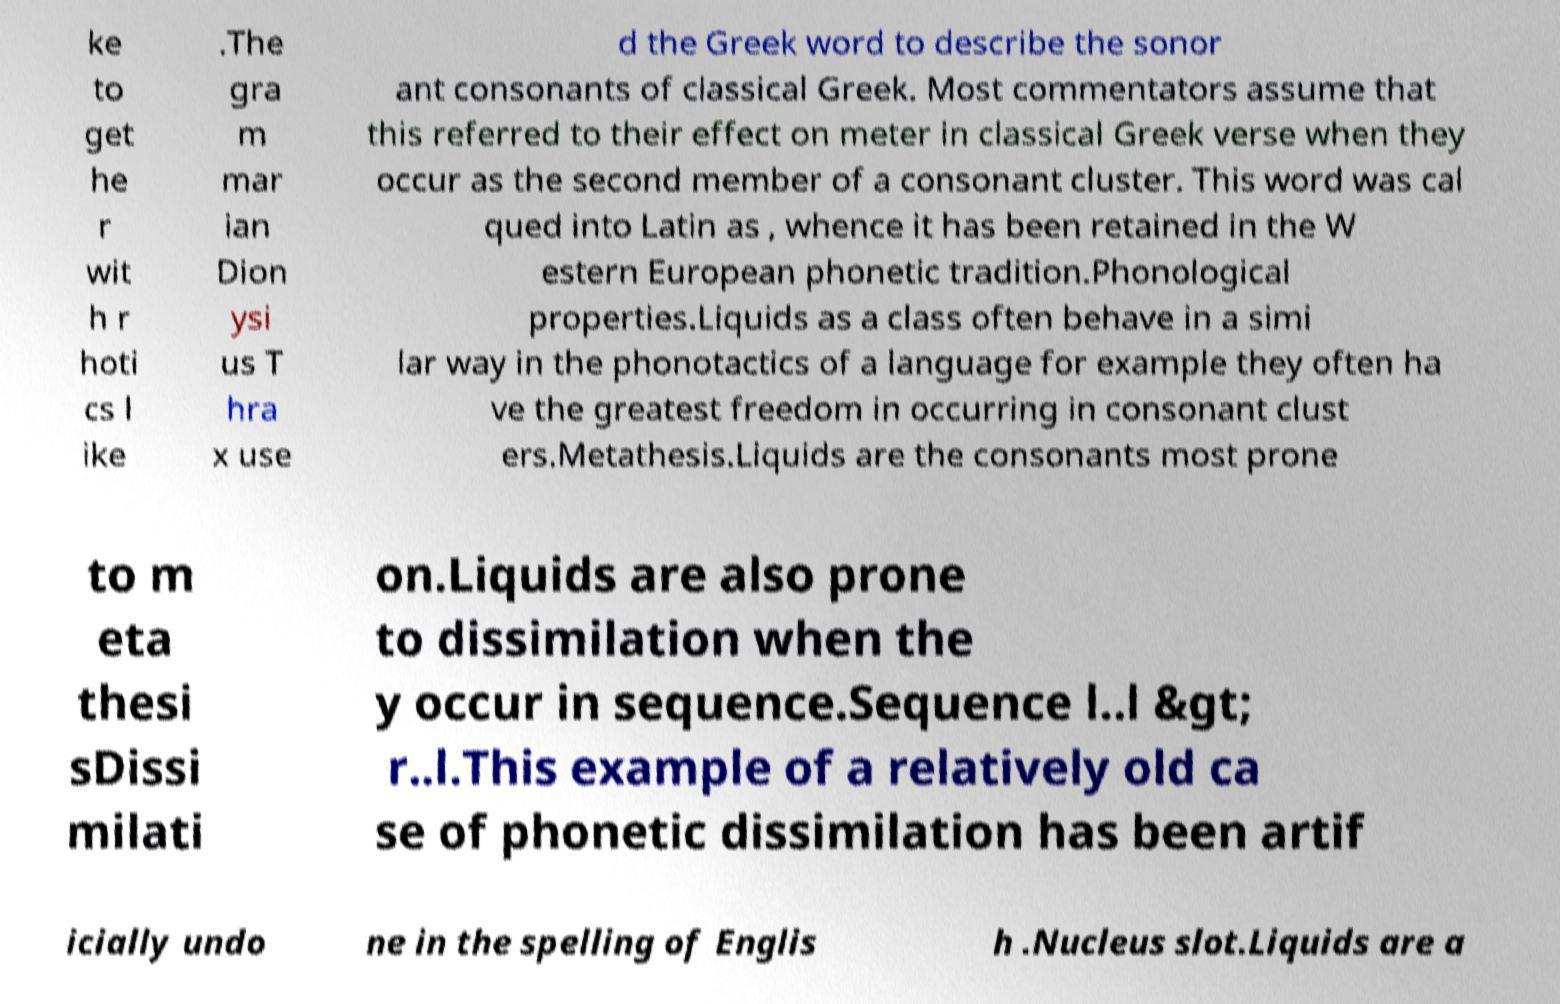Please read and relay the text visible in this image. What does it say? ke to get he r wit h r hoti cs l ike .The gra m mar ian Dion ysi us T hra x use d the Greek word to describe the sonor ant consonants of classical Greek. Most commentators assume that this referred to their effect on meter in classical Greek verse when they occur as the second member of a consonant cluster. This word was cal qued into Latin as , whence it has been retained in the W estern European phonetic tradition.Phonological properties.Liquids as a class often behave in a simi lar way in the phonotactics of a language for example they often ha ve the greatest freedom in occurring in consonant clust ers.Metathesis.Liquids are the consonants most prone to m eta thesi sDissi milati on.Liquids are also prone to dissimilation when the y occur in sequence.Sequence l..l &gt; r..l.This example of a relatively old ca se of phonetic dissimilation has been artif icially undo ne in the spelling of Englis h .Nucleus slot.Liquids are a 